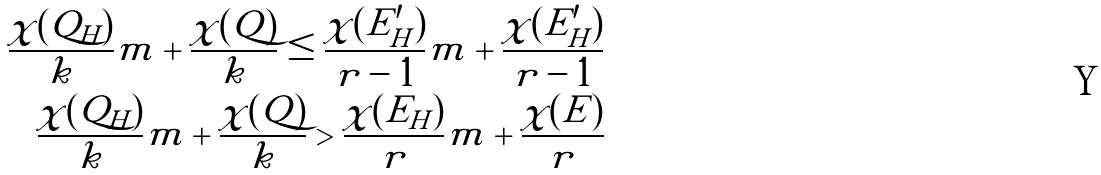Convert formula to latex. <formula><loc_0><loc_0><loc_500><loc_500>\frac { \chi ( Q _ { H } ) } { k } m + \frac { \chi ( Q ) } { k } \leq \frac { \chi ( E ^ { \prime } _ { H } ) } { r - 1 } m + \frac { \chi ( E ^ { \prime } _ { H } ) } { r - 1 } \\ \frac { \chi ( Q _ { H } ) } { k } m + \frac { \chi ( Q ) } { k } > \frac { \chi ( E _ { H } ) } { r } m + \frac { \chi ( E ) } { r } \\</formula> 